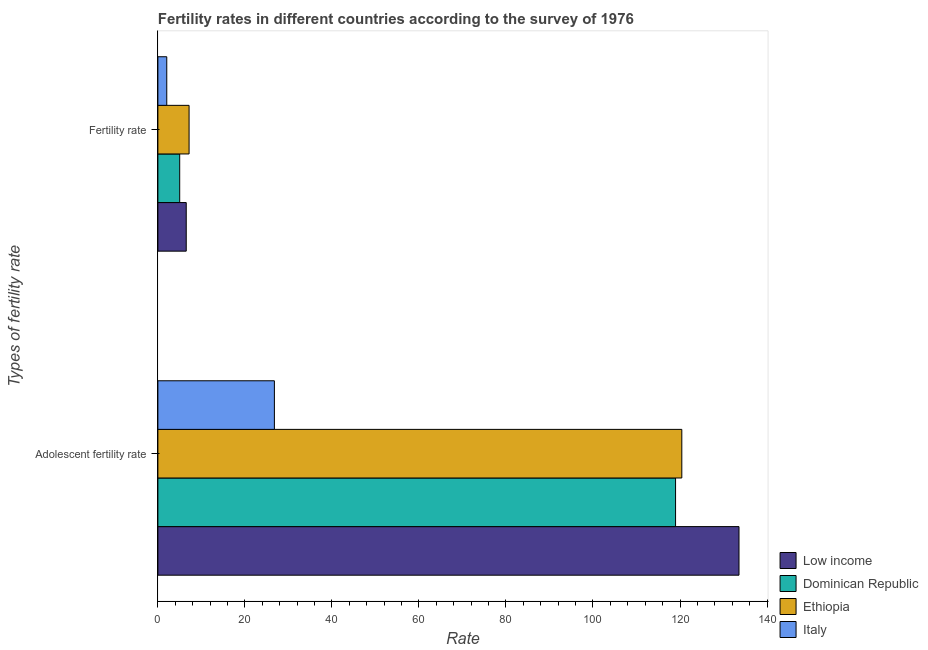How many groups of bars are there?
Your answer should be very brief. 2. Are the number of bars on each tick of the Y-axis equal?
Make the answer very short. Yes. How many bars are there on the 1st tick from the bottom?
Your answer should be very brief. 4. What is the label of the 1st group of bars from the top?
Give a very brief answer. Fertility rate. What is the adolescent fertility rate in Italy?
Offer a very short reply. 26.78. Across all countries, what is the maximum fertility rate?
Offer a terse response. 7.17. Across all countries, what is the minimum adolescent fertility rate?
Offer a terse response. 26.78. What is the total fertility rate in the graph?
Provide a short and direct response. 20.74. What is the difference between the fertility rate in Dominican Republic and that in Ethiopia?
Give a very brief answer. -2.15. What is the difference between the adolescent fertility rate in Dominican Republic and the fertility rate in Italy?
Your answer should be compact. 116.94. What is the average adolescent fertility rate per country?
Make the answer very short. 99.94. What is the difference between the adolescent fertility rate and fertility rate in Low income?
Offer a terse response. 127.05. In how many countries, is the adolescent fertility rate greater than 52 ?
Your answer should be compact. 3. What is the ratio of the adolescent fertility rate in Low income to that in Italy?
Offer a terse response. 4.99. Is the fertility rate in Ethiopia less than that in Low income?
Provide a short and direct response. No. What does the 2nd bar from the top in Fertility rate represents?
Your answer should be compact. Ethiopia. What does the 4th bar from the bottom in Adolescent fertility rate represents?
Offer a very short reply. Italy. Are all the bars in the graph horizontal?
Make the answer very short. Yes. How many countries are there in the graph?
Provide a short and direct response. 4. Are the values on the major ticks of X-axis written in scientific E-notation?
Provide a succinct answer. No. Does the graph contain any zero values?
Your answer should be compact. No. Does the graph contain grids?
Your answer should be very brief. No. Where does the legend appear in the graph?
Your answer should be compact. Bottom right. What is the title of the graph?
Keep it short and to the point. Fertility rates in different countries according to the survey of 1976. What is the label or title of the X-axis?
Offer a very short reply. Rate. What is the label or title of the Y-axis?
Give a very brief answer. Types of fertility rate. What is the Rate of Low income in Adolescent fertility rate?
Offer a very short reply. 133.56. What is the Rate in Dominican Republic in Adolescent fertility rate?
Your answer should be compact. 118.98. What is the Rate of Ethiopia in Adolescent fertility rate?
Your answer should be very brief. 120.42. What is the Rate of Italy in Adolescent fertility rate?
Provide a short and direct response. 26.78. What is the Rate of Low income in Fertility rate?
Give a very brief answer. 6.52. What is the Rate in Dominican Republic in Fertility rate?
Your answer should be compact. 5.01. What is the Rate in Ethiopia in Fertility rate?
Offer a very short reply. 7.17. What is the Rate in Italy in Fertility rate?
Your answer should be compact. 2.04. Across all Types of fertility rate, what is the maximum Rate of Low income?
Ensure brevity in your answer.  133.56. Across all Types of fertility rate, what is the maximum Rate of Dominican Republic?
Make the answer very short. 118.98. Across all Types of fertility rate, what is the maximum Rate of Ethiopia?
Offer a terse response. 120.42. Across all Types of fertility rate, what is the maximum Rate of Italy?
Provide a succinct answer. 26.78. Across all Types of fertility rate, what is the minimum Rate of Low income?
Your response must be concise. 6.52. Across all Types of fertility rate, what is the minimum Rate of Dominican Republic?
Your answer should be very brief. 5.01. Across all Types of fertility rate, what is the minimum Rate in Ethiopia?
Offer a very short reply. 7.17. Across all Types of fertility rate, what is the minimum Rate of Italy?
Make the answer very short. 2.04. What is the total Rate of Low income in the graph?
Your response must be concise. 140.08. What is the total Rate in Dominican Republic in the graph?
Offer a very short reply. 124. What is the total Rate of Ethiopia in the graph?
Keep it short and to the point. 127.59. What is the total Rate in Italy in the graph?
Offer a terse response. 28.82. What is the difference between the Rate of Low income in Adolescent fertility rate and that in Fertility rate?
Your answer should be compact. 127.05. What is the difference between the Rate of Dominican Republic in Adolescent fertility rate and that in Fertility rate?
Give a very brief answer. 113.97. What is the difference between the Rate of Ethiopia in Adolescent fertility rate and that in Fertility rate?
Offer a very short reply. 113.25. What is the difference between the Rate in Italy in Adolescent fertility rate and that in Fertility rate?
Your answer should be compact. 24.74. What is the difference between the Rate in Low income in Adolescent fertility rate and the Rate in Dominican Republic in Fertility rate?
Make the answer very short. 128.55. What is the difference between the Rate in Low income in Adolescent fertility rate and the Rate in Ethiopia in Fertility rate?
Ensure brevity in your answer.  126.39. What is the difference between the Rate in Low income in Adolescent fertility rate and the Rate in Italy in Fertility rate?
Offer a very short reply. 131.52. What is the difference between the Rate of Dominican Republic in Adolescent fertility rate and the Rate of Ethiopia in Fertility rate?
Keep it short and to the point. 111.81. What is the difference between the Rate in Dominican Republic in Adolescent fertility rate and the Rate in Italy in Fertility rate?
Your answer should be compact. 116.94. What is the difference between the Rate of Ethiopia in Adolescent fertility rate and the Rate of Italy in Fertility rate?
Ensure brevity in your answer.  118.38. What is the average Rate of Low income per Types of fertility rate?
Offer a terse response. 70.04. What is the average Rate of Dominican Republic per Types of fertility rate?
Offer a terse response. 62. What is the average Rate in Ethiopia per Types of fertility rate?
Ensure brevity in your answer.  63.79. What is the average Rate in Italy per Types of fertility rate?
Give a very brief answer. 14.41. What is the difference between the Rate in Low income and Rate in Dominican Republic in Adolescent fertility rate?
Offer a very short reply. 14.58. What is the difference between the Rate of Low income and Rate of Ethiopia in Adolescent fertility rate?
Offer a terse response. 13.14. What is the difference between the Rate in Low income and Rate in Italy in Adolescent fertility rate?
Your answer should be very brief. 106.78. What is the difference between the Rate of Dominican Republic and Rate of Ethiopia in Adolescent fertility rate?
Your answer should be very brief. -1.44. What is the difference between the Rate of Dominican Republic and Rate of Italy in Adolescent fertility rate?
Your response must be concise. 92.2. What is the difference between the Rate in Ethiopia and Rate in Italy in Adolescent fertility rate?
Provide a short and direct response. 93.64. What is the difference between the Rate of Low income and Rate of Dominican Republic in Fertility rate?
Provide a succinct answer. 1.5. What is the difference between the Rate of Low income and Rate of Ethiopia in Fertility rate?
Offer a very short reply. -0.65. What is the difference between the Rate of Low income and Rate of Italy in Fertility rate?
Your answer should be very brief. 4.48. What is the difference between the Rate of Dominican Republic and Rate of Ethiopia in Fertility rate?
Your answer should be compact. -2.15. What is the difference between the Rate in Dominican Republic and Rate in Italy in Fertility rate?
Offer a terse response. 2.97. What is the difference between the Rate in Ethiopia and Rate in Italy in Fertility rate?
Your answer should be compact. 5.13. What is the ratio of the Rate in Low income in Adolescent fertility rate to that in Fertility rate?
Your answer should be very brief. 20.5. What is the ratio of the Rate of Dominican Republic in Adolescent fertility rate to that in Fertility rate?
Provide a short and direct response. 23.73. What is the ratio of the Rate in Ethiopia in Adolescent fertility rate to that in Fertility rate?
Ensure brevity in your answer.  16.8. What is the ratio of the Rate in Italy in Adolescent fertility rate to that in Fertility rate?
Ensure brevity in your answer.  13.13. What is the difference between the highest and the second highest Rate of Low income?
Give a very brief answer. 127.05. What is the difference between the highest and the second highest Rate in Dominican Republic?
Ensure brevity in your answer.  113.97. What is the difference between the highest and the second highest Rate of Ethiopia?
Provide a succinct answer. 113.25. What is the difference between the highest and the second highest Rate in Italy?
Provide a succinct answer. 24.74. What is the difference between the highest and the lowest Rate in Low income?
Ensure brevity in your answer.  127.05. What is the difference between the highest and the lowest Rate in Dominican Republic?
Give a very brief answer. 113.97. What is the difference between the highest and the lowest Rate of Ethiopia?
Offer a very short reply. 113.25. What is the difference between the highest and the lowest Rate in Italy?
Your answer should be compact. 24.74. 